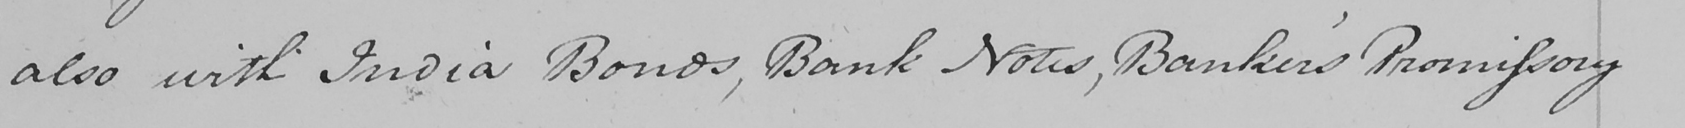Please provide the text content of this handwritten line. also with India Bonds , Bank Notes , Banker ' s Promissory 